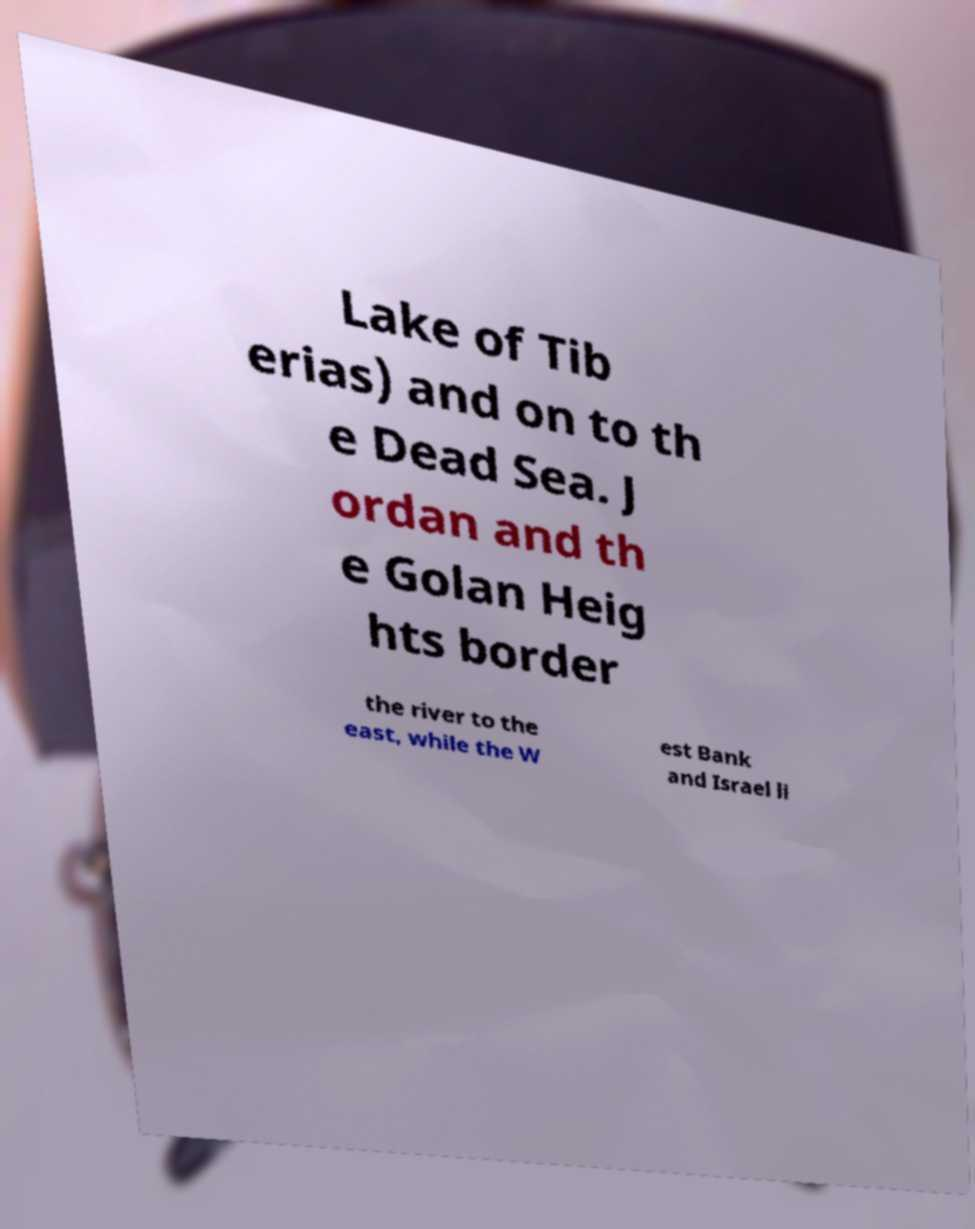Could you assist in decoding the text presented in this image and type it out clearly? Lake of Tib erias) and on to th e Dead Sea. J ordan and th e Golan Heig hts border the river to the east, while the W est Bank and Israel li 